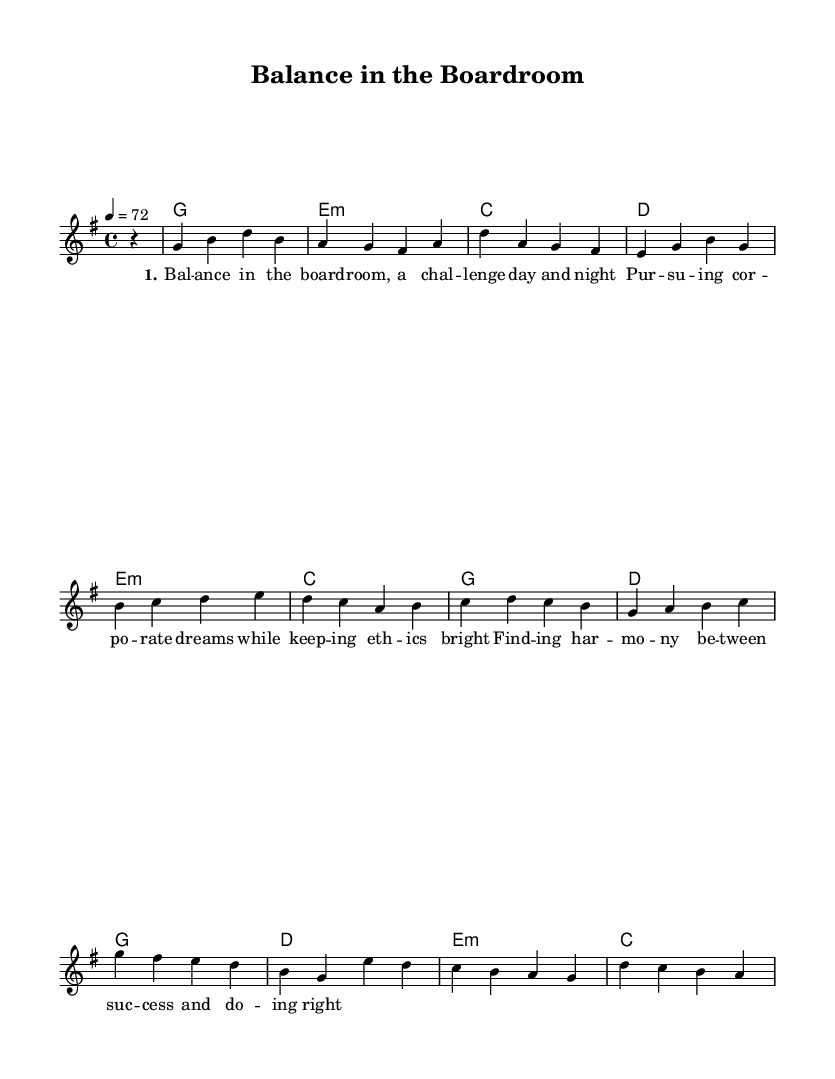What is the key signature of this music? The key signature is indicated by the 'g' symbol at the beginning of the sheet music. In this case, it represents G major, which has one sharp (F#).
Answer: G major What is the time signature of the piece? The time signature can be found right after the key signature. It is 4/4, meaning there are four beats in each measure and the quarter note gets one beat.
Answer: 4/4 What is the tempo marking for the music? The tempo is shown as "4 = 72" beneath the global instructions, indicating the beat per minute. This means the quarter note (which is the '1' in '4') should be played at 72 beats per minute.
Answer: 72 How many measures are there in the chorus? To find the number of measures in the chorus, one would count each bar within the chorus section as notated in the melody. There are four measures in the chorus part.
Answer: 4 What is the primary theme expressed in the lyrics? The lyrics convey a theme of balancing corporate responsibilities and ethics, represented in phrases like "finding harmony between success and doing right." This focuses on the interconnectedness of personal ethics with professional aspirations.
Answer: Work-life balance Which chord is played during the first measure of the verse? The first measure in the Verse section shows "g" which indicates the chord G major is played. This can be determined by the notation under the 'Harmonies' section.
Answer: G 